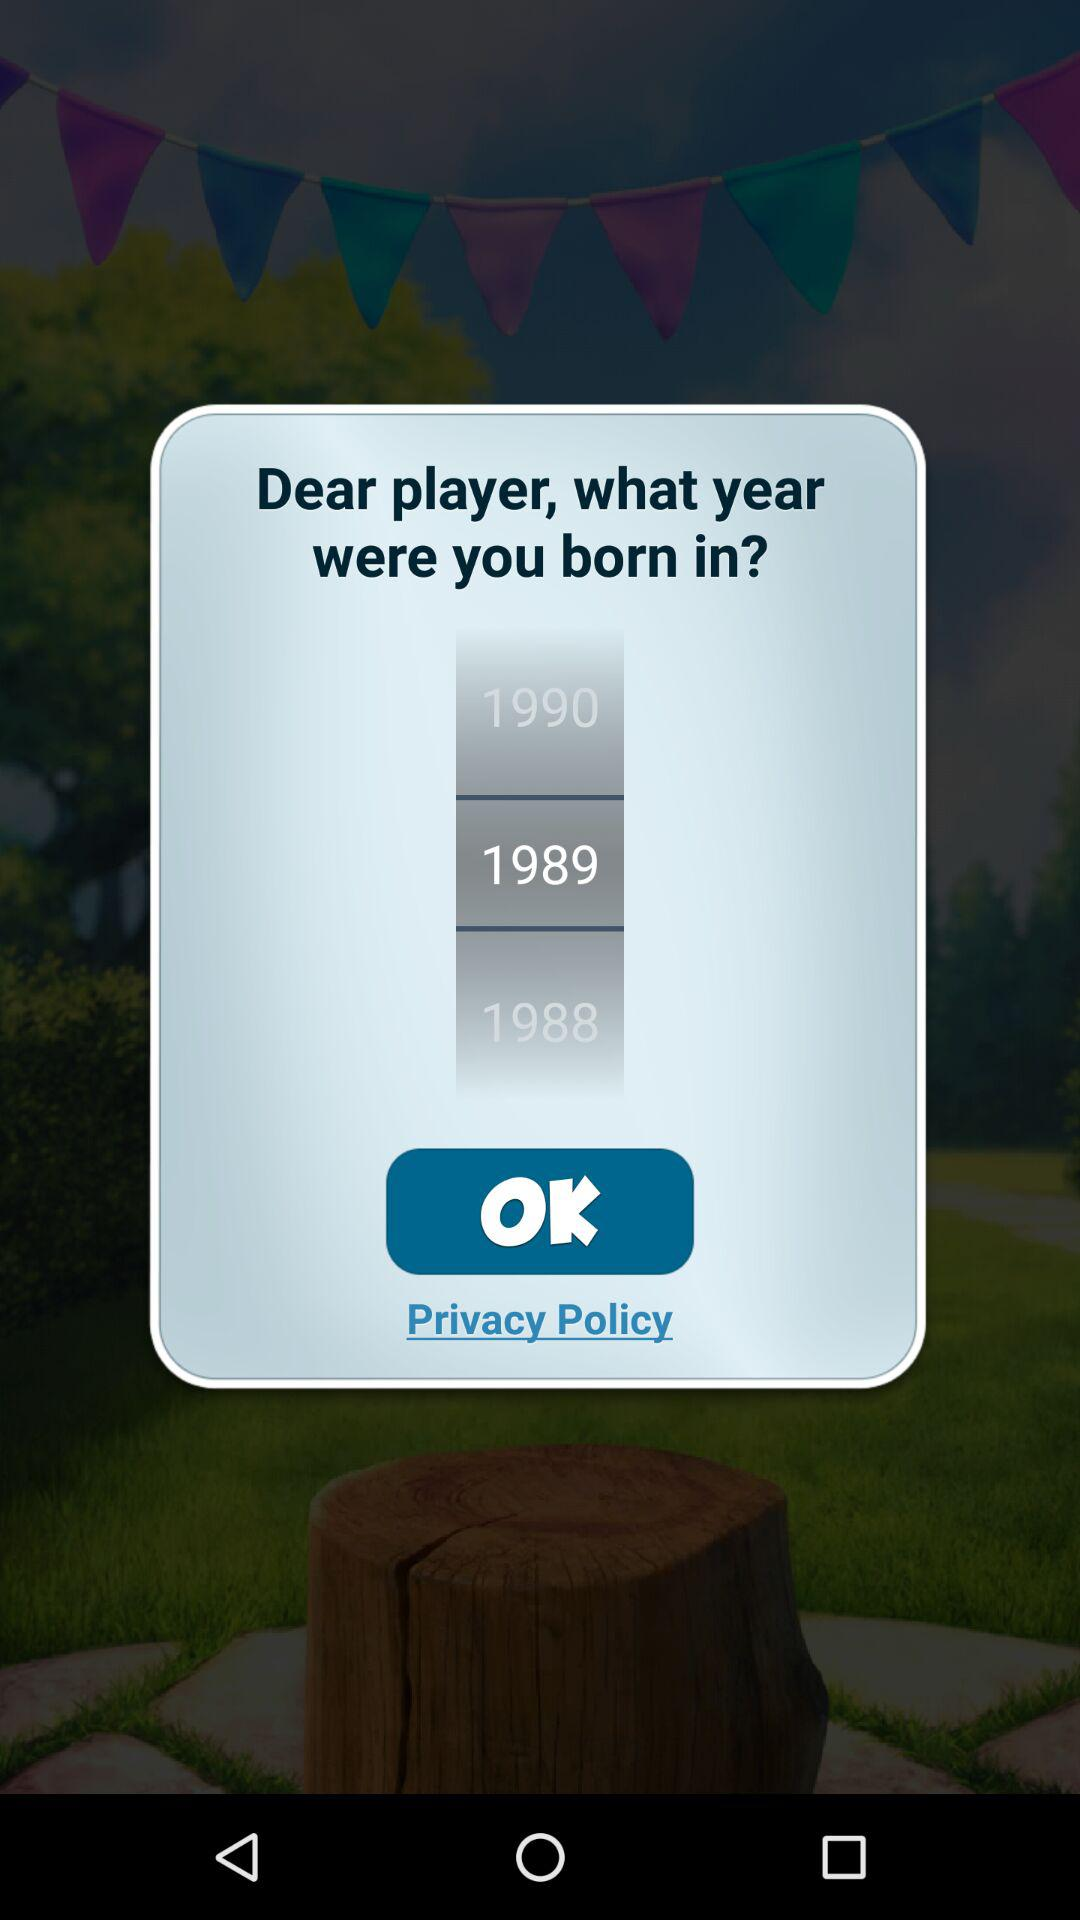Which year is selected? The selected year is 1989. 